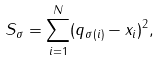<formula> <loc_0><loc_0><loc_500><loc_500>S _ { \sigma } = \sum _ { i = 1 } ^ { N } ( { q } _ { \sigma ( i ) } - { x } _ { i } ) ^ { 2 } ,</formula> 